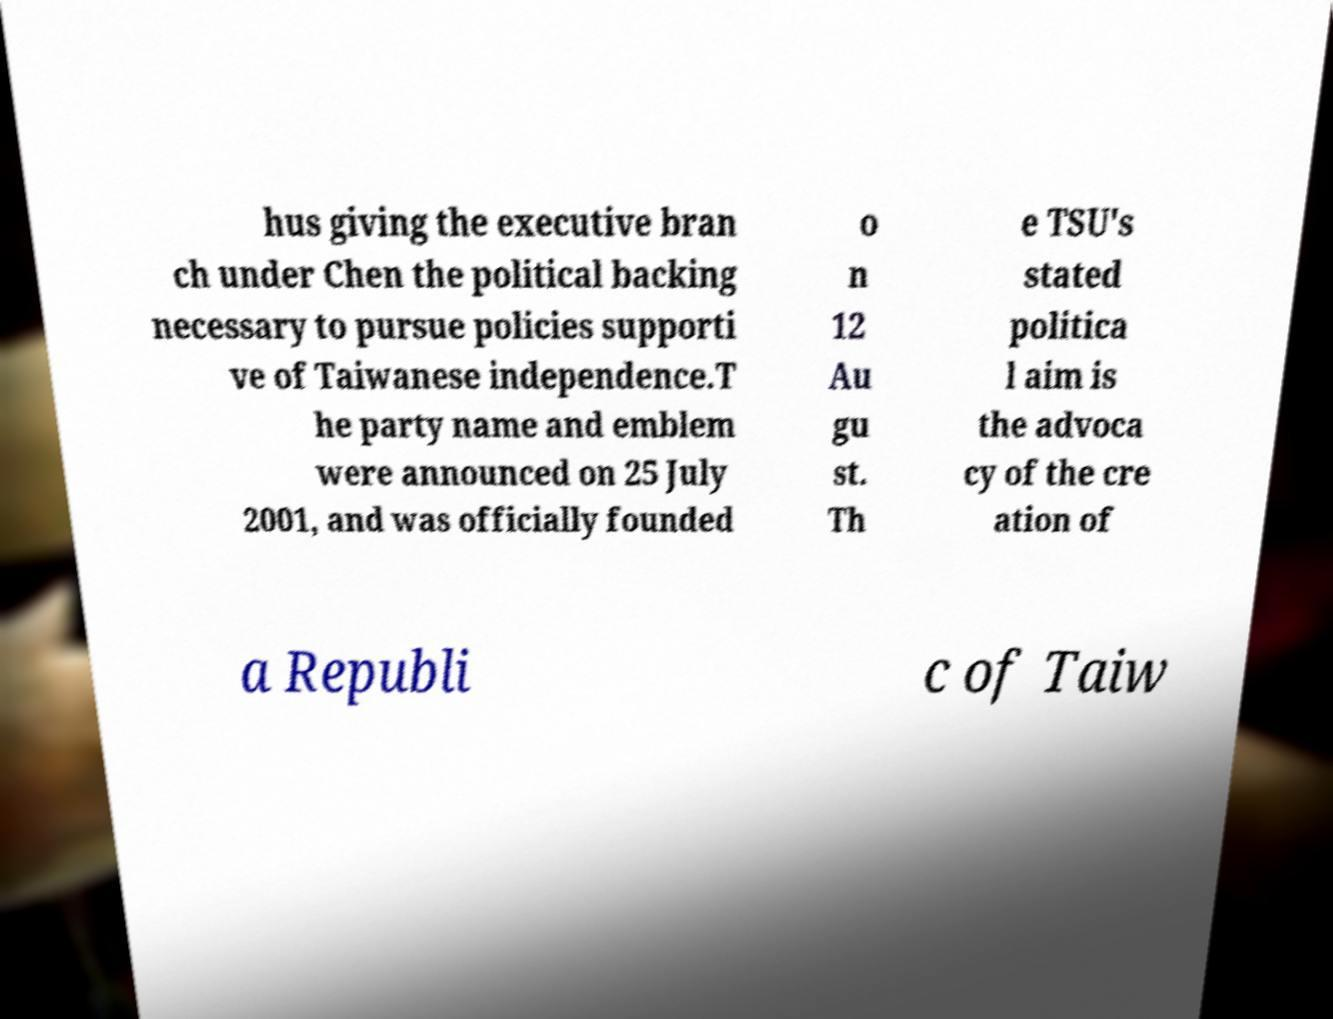What messages or text are displayed in this image? I need them in a readable, typed format. hus giving the executive bran ch under Chen the political backing necessary to pursue policies supporti ve of Taiwanese independence.T he party name and emblem were announced on 25 July 2001, and was officially founded o n 12 Au gu st. Th e TSU's stated politica l aim is the advoca cy of the cre ation of a Republi c of Taiw 